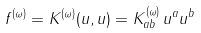Convert formula to latex. <formula><loc_0><loc_0><loc_500><loc_500>f ^ { ( \omega ) } = K ^ { ( \omega ) } ( u , u ) = K ^ { ( \omega ) } _ { a b } \, u ^ { a } u ^ { b }</formula> 